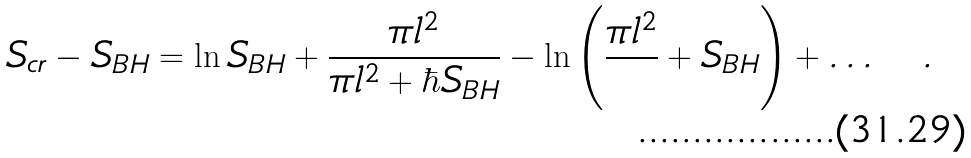Convert formula to latex. <formula><loc_0><loc_0><loc_500><loc_500>S _ { c r } - S _ { B H } = \ln S _ { B H } + \frac { \pi l ^ { 2 } } { \pi l ^ { 2 } + \hbar { S } _ { B H } } - \ln \left ( \frac { \pi l ^ { 2 } } { } + S _ { B H } \right ) + \dots \quad .</formula> 